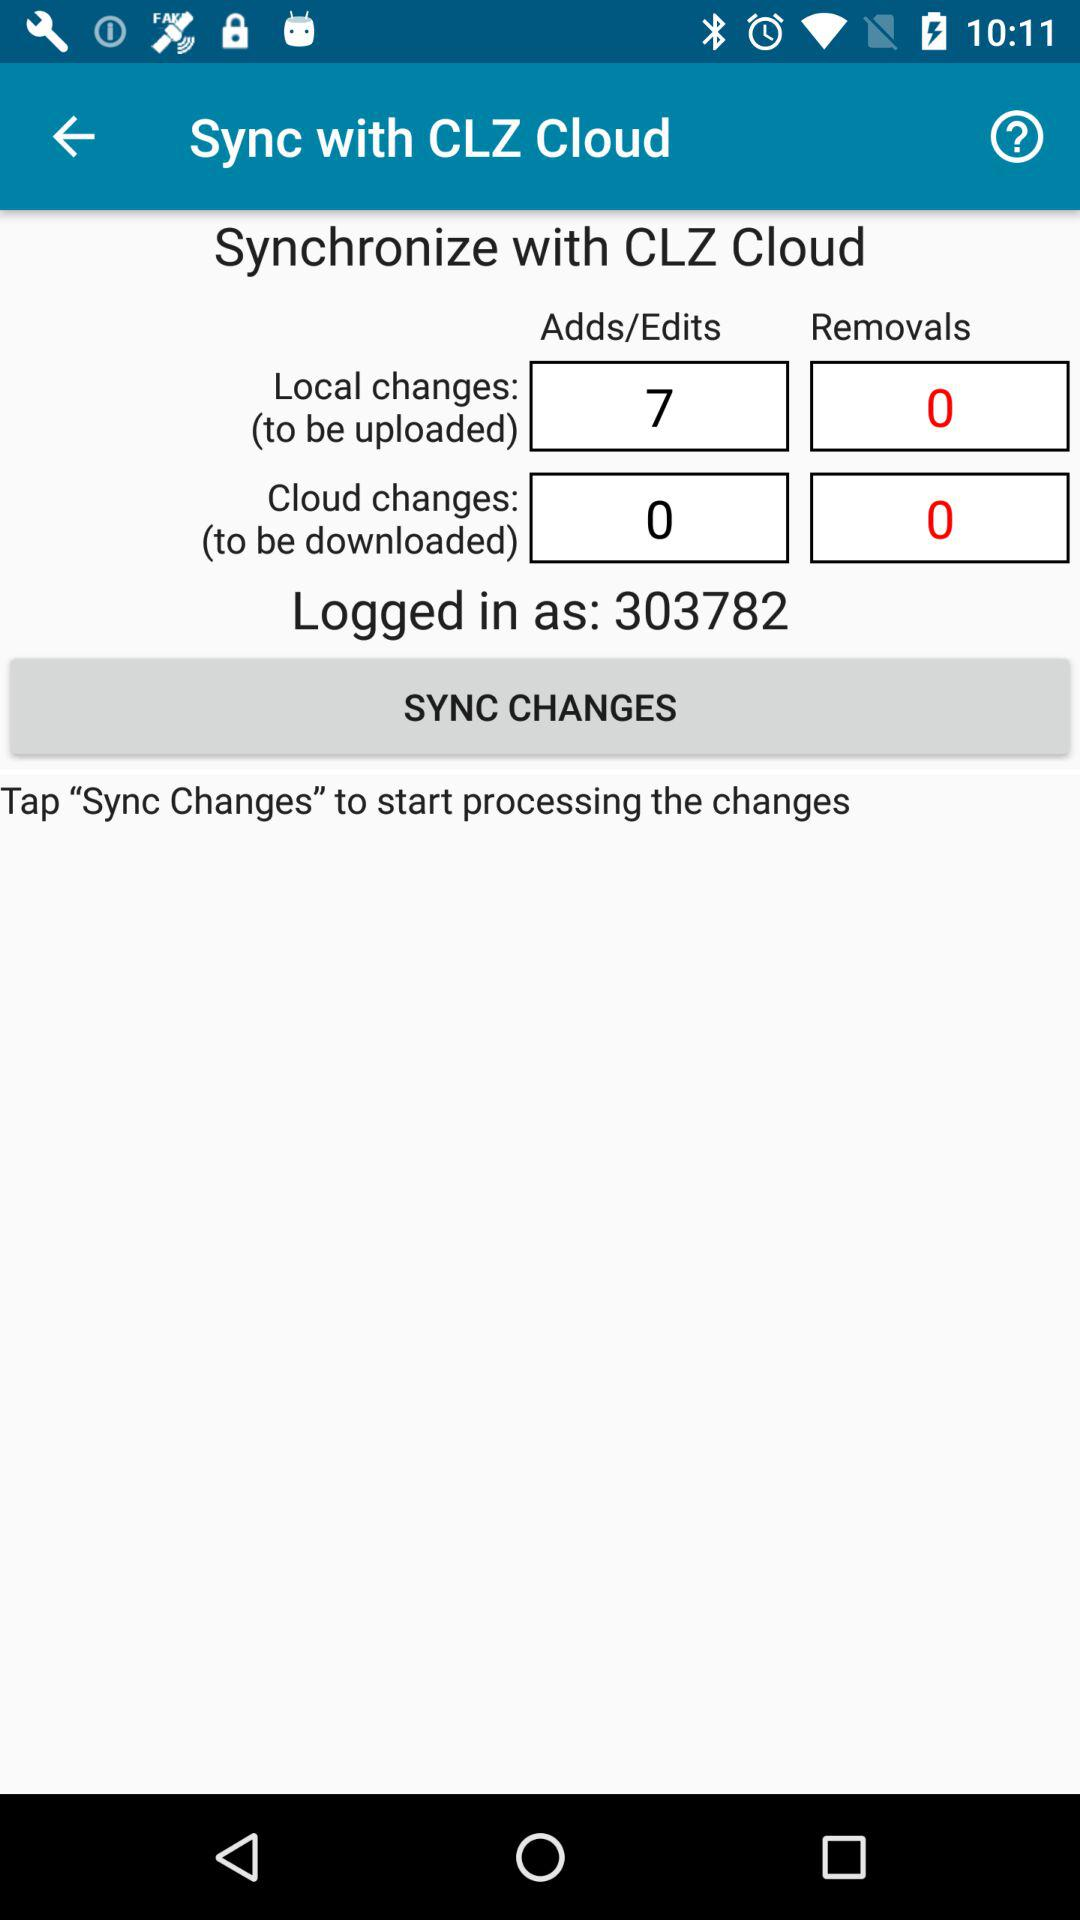Could there be any risks involved in syncing data with the cloud, and if so, what are they? Syncing data with the cloud is generally secure, but it's not without risks. Possible concerns include unintended data breaches, unauthorized access if security protocols are not robust, and the potential for data loss if the cloud server itself has issues. Users must ensure strong passwords, secure connections, and perhaps enable two-factor authentication to mitigate these risks. 